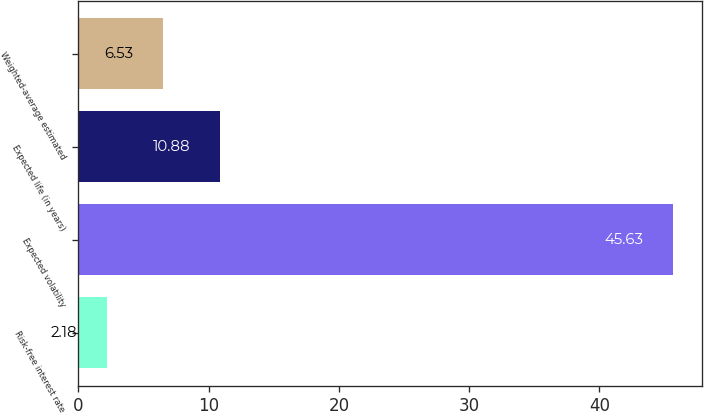Convert chart. <chart><loc_0><loc_0><loc_500><loc_500><bar_chart><fcel>Risk-free interest rate<fcel>Expected volatility<fcel>Expected life (in years)<fcel>Weighted-average estimated<nl><fcel>2.18<fcel>45.63<fcel>10.88<fcel>6.53<nl></chart> 